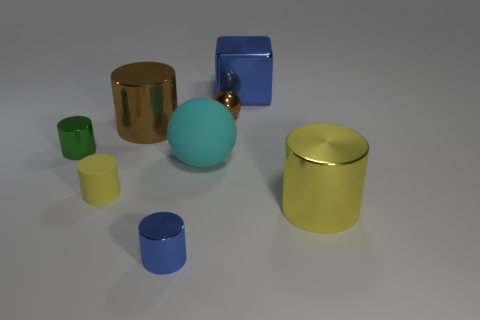How many objects are big cyan things or blue shiny things that are to the left of the large shiny block?
Give a very brief answer. 2. Is the small cylinder to the left of the yellow matte object made of the same material as the small yellow thing?
Your answer should be very brief. No. What is the color of the metal cylinder that is the same size as the yellow metallic object?
Keep it short and to the point. Brown. Are there any other yellow objects that have the same shape as the tiny yellow rubber thing?
Make the answer very short. Yes. What color is the big object that is behind the small metallic object behind the tiny metal thing that is to the left of the small yellow matte object?
Keep it short and to the point. Blue. How many rubber things are tiny cyan cubes or tiny cylinders?
Keep it short and to the point. 1. Is the number of large shiny cylinders to the right of the large blue metal thing greater than the number of small shiny spheres that are in front of the big brown shiny thing?
Give a very brief answer. Yes. How many other objects are the same size as the brown cylinder?
Provide a short and direct response. 3. There is a yellow cylinder on the left side of the big cylinder that is on the right side of the blue cylinder; what size is it?
Offer a very short reply. Small. What number of tiny things are blocks or cyan things?
Your answer should be compact. 0. 